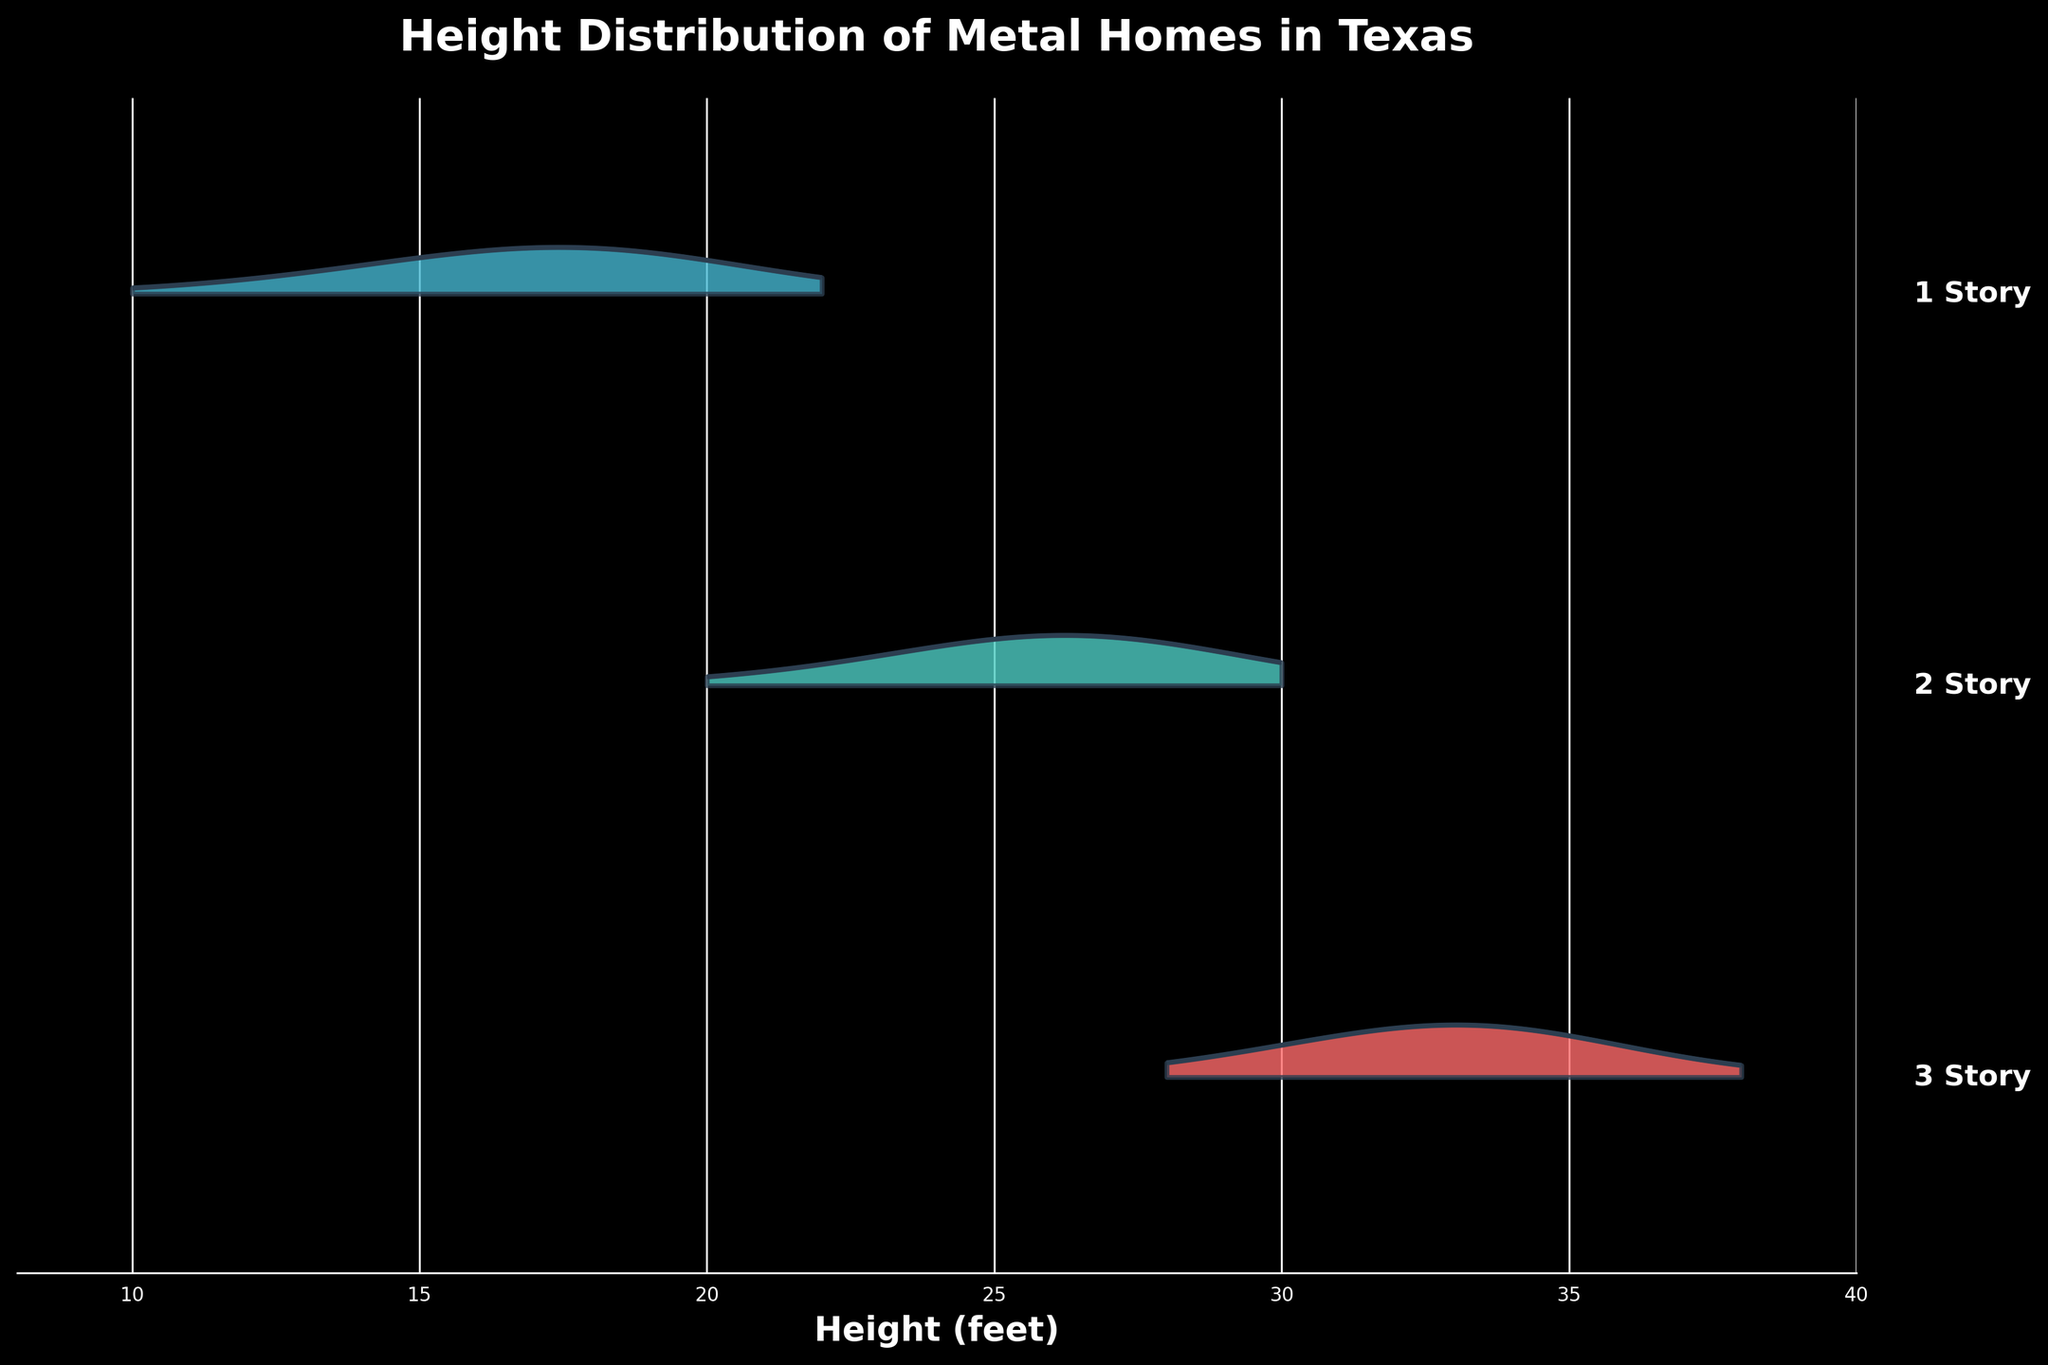What's the title of the plot? Look at the top of the plot, where the title is usually placed.
Answer: Height Distribution of Metal Homes in Texas What is the highest height observed for 3-story metal homes? Identify the range and peak of the distribution for 3-story homes (the topmost curve). The highest height should be at the end of the x-axis range for this category.
Answer: 38 feet Which category has the widest range of home heights? Compare the horizontal span of the distributions for each story category. The one with the largest span represents the widest range.
Answer: 3-story homes What is the most common height for 2-story homes? Look for the peak of the distribution curve for 2-story homes (middle curve). The height at this peak is the most common.
Answer: 26 feet How do the height distributions of 1-story and 2-story homes compare? Compare the center and spread of both distributions. Note the peaks and how the distribution tails off.
Answer: 1-story homes have lower average heights; 2-story homes have higher average heights and greater range What story category has the lowest frequency for any given height? Identify the lowest peaks in the distributions. On the graph, the lowest peaks correspond to the lowest frequencies.
Answer: 3-story homes at 38 feet How does the rise in height distribution between 2-story and 3-story homes differ? Notice the distribution curves for both 2-story and 3-story homes. Compare how quickly or gradually the curve rises and falls within their range.
Answer: 3-story homes rise more gradually than 2-story homes Which heights are shared between all categories? Determine the range where all three distributions overlap on the x-axis. The shared heights are where the distributions intersect.
Answer: 20 to 30 feet Are the distributions for 1-story and 3-story homes overlapping at any point? Check the areas where the curves for 1-story and 3-story homes may touch or overlap along the x-axis range.
Answer: No What can be inferred about the spread of 1-story homes compared to the others? Assess the breadth of the 1-story distribution range compared to 2-story and 3-story homes, noting if it is more narrow or extensive.
Answer: 1-story homes have a narrower spread 